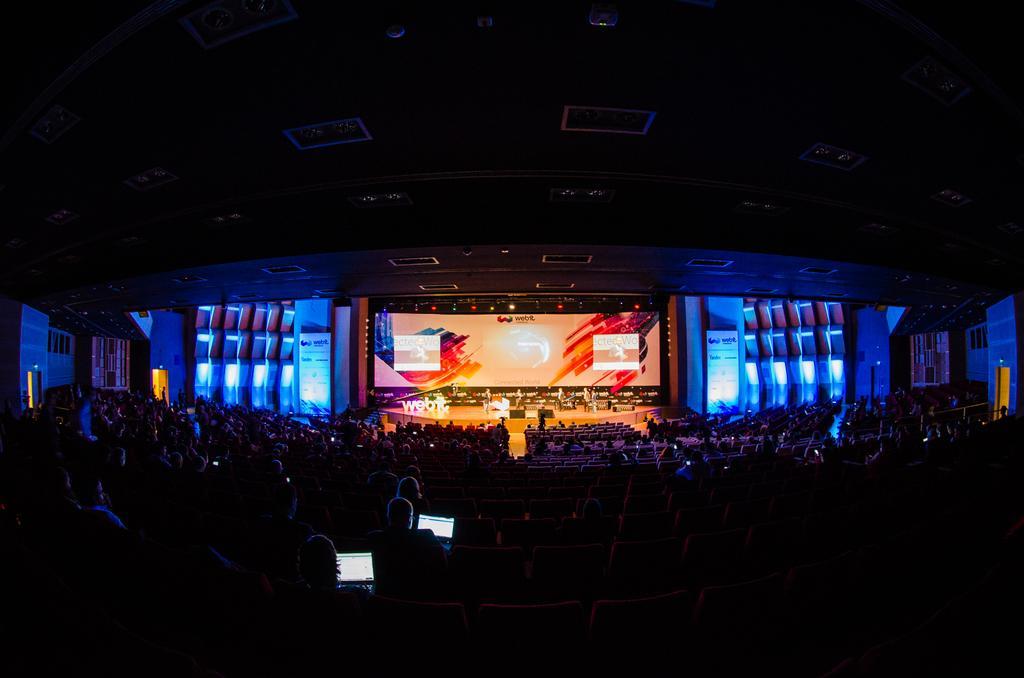In one or two sentences, can you explain what this image depicts? This picture describes about group of people, in the background we can see few lights, hoardings and a projector screen, and also we can see few laptops. 